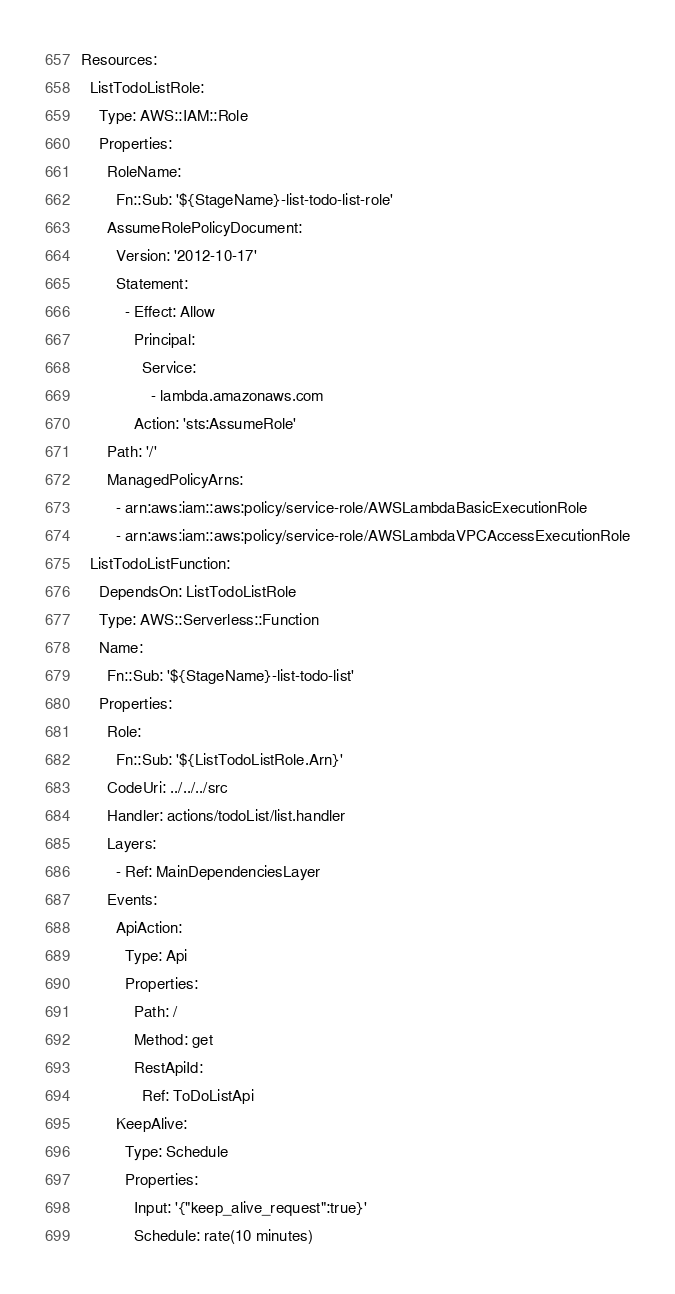Convert code to text. <code><loc_0><loc_0><loc_500><loc_500><_YAML_>Resources:
  ListTodoListRole:
    Type: AWS::IAM::Role
    Properties:
      RoleName:
        Fn::Sub: '${StageName}-list-todo-list-role'
      AssumeRolePolicyDocument:
        Version: '2012-10-17'
        Statement:
          - Effect: Allow
            Principal:
              Service:
                - lambda.amazonaws.com
            Action: 'sts:AssumeRole'
      Path: '/'
      ManagedPolicyArns:
        - arn:aws:iam::aws:policy/service-role/AWSLambdaBasicExecutionRole
        - arn:aws:iam::aws:policy/service-role/AWSLambdaVPCAccessExecutionRole
  ListTodoListFunction:
    DependsOn: ListTodoListRole
    Type: AWS::Serverless::Function
    Name:
      Fn::Sub: '${StageName}-list-todo-list'
    Properties:
      Role:
        Fn::Sub: '${ListTodoListRole.Arn}'
      CodeUri: ../../../src
      Handler: actions/todoList/list.handler
      Layers:
        - Ref: MainDependenciesLayer
      Events:
        ApiAction:
          Type: Api
          Properties:
            Path: /
            Method: get
            RestApiId:
              Ref: ToDoListApi
        KeepAlive:
          Type: Schedule
          Properties:
            Input: '{"keep_alive_request":true}'
            Schedule: rate(10 minutes)</code> 